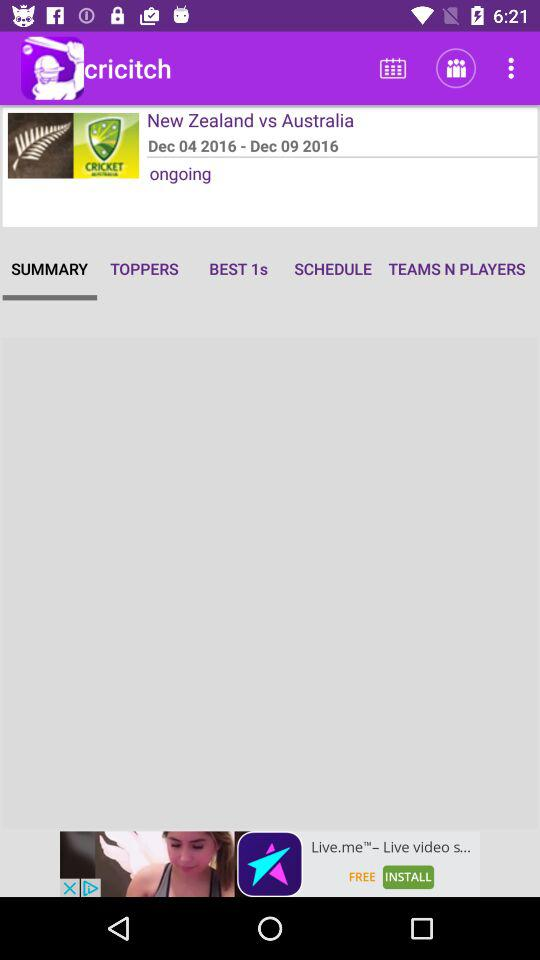What is the starting date of the series? The starting date of the series is December 4, 2016. 